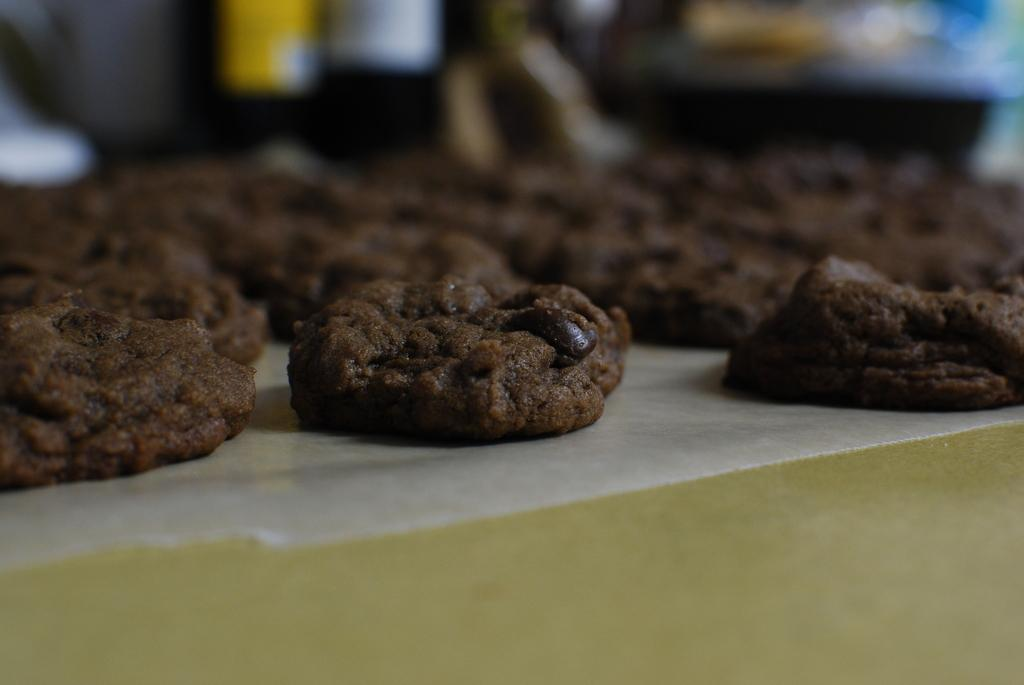What type of cookie is visible in the image? There is a chocolate chip cookie in the image. What is the cookie placed on? The cookie is placed on a paper. Can you describe the view at the top of the image? The view at the top of the image is blurry. What type of teeth can be seen in the image? There are no teeth visible in the image; it features a chocolate chip cookie placed on a paper. Is there a bomb present in the image? There is no bomb present in the image. 